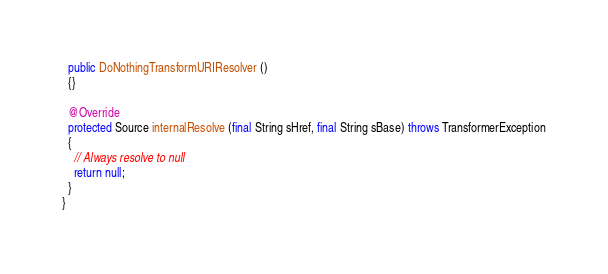<code> <loc_0><loc_0><loc_500><loc_500><_Java_>  public DoNothingTransformURIResolver ()
  {}

  @Override
  protected Source internalResolve (final String sHref, final String sBase) throws TransformerException
  {
    // Always resolve to null
    return null;
  }
}
</code> 